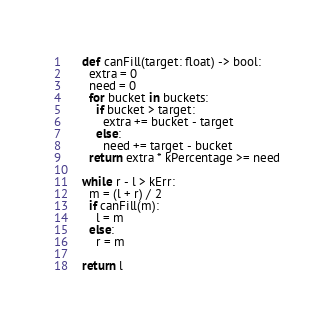<code> <loc_0><loc_0><loc_500><loc_500><_Python_>
    def canFill(target: float) -> bool:
      extra = 0
      need = 0
      for bucket in buckets:
        if bucket > target:
          extra += bucket - target
        else:
          need += target - bucket
      return extra * kPercentage >= need

    while r - l > kErr:
      m = (l + r) / 2
      if canFill(m):
        l = m
      else:
        r = m

    return l
</code> 